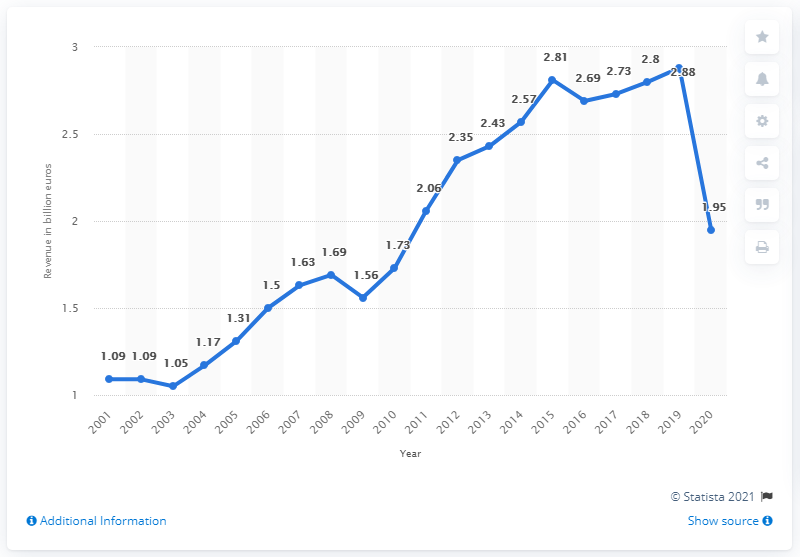Give some essential details in this illustration. According to available information, Hugo Boss' revenue in 2020 was approximately 1.95 billion USD. 